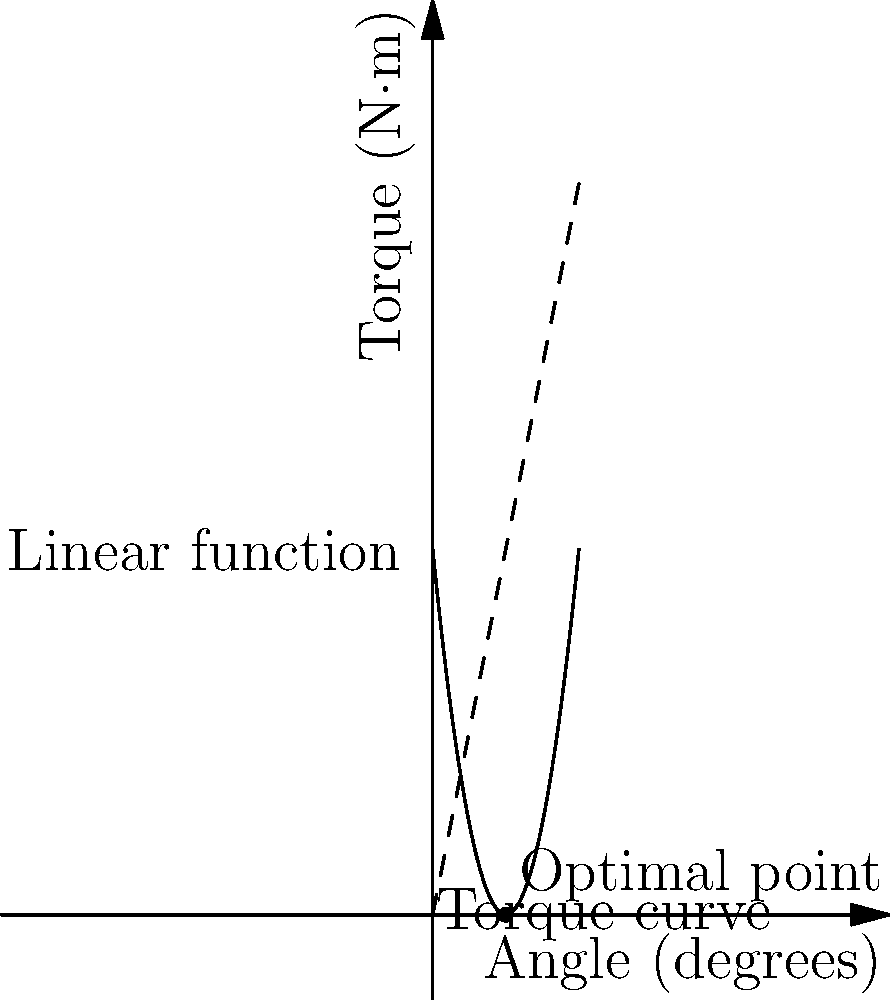As a plastic bottle cap manufacturer, you're designing a new threaded cap. The torque required to open the cap is modeled by the function $T(\theta) = 0.5\theta^2 - 10\theta + 50$, where $T$ is the torque in N·m and $\theta$ is the rotation angle in degrees. To ensure easy opening, you want to minimize the maximum torque. Find the optimal angle $\theta$ that minimizes the maximum torque using derivatives. To find the optimal angle that minimizes the maximum torque, we need to follow these steps:

1) The torque function is given by:
   $T(\theta) = 0.5\theta^2 - 10\theta + 50$

2) To find the minimum point, we need to find where the derivative equals zero:
   $T'(\theta) = \theta - 10$

3) Set the derivative to zero and solve for $\theta$:
   $T'(\theta) = 0$
   $\theta - 10 = 0$
   $\theta = 10$

4) To confirm this is a minimum (not a maximum), check the second derivative:
   $T''(\theta) = 1 > 0$, which confirms it's a minimum.

5) Therefore, the optimal angle is 10 degrees.

6) The minimum torque at this angle is:
   $T(10) = 0.5(10)^2 - 10(10) + 50 = 50 - 100 + 50 = 0$ N·m

This optimal angle of 10 degrees minimizes the maximum torque required to open the cap, making it easier for consumers to use while still maintaining a secure seal.
Answer: 10 degrees 